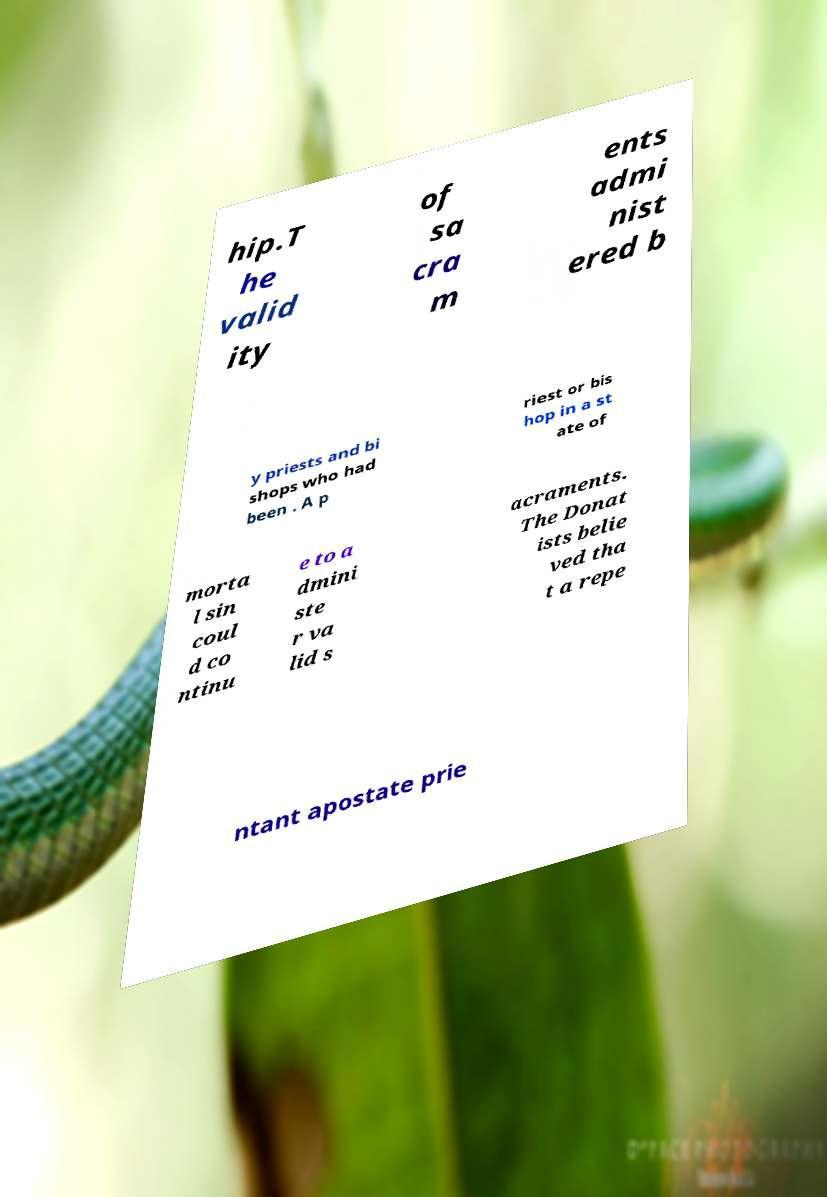For documentation purposes, I need the text within this image transcribed. Could you provide that? hip.T he valid ity of sa cra m ents admi nist ered b y priests and bi shops who had been . A p riest or bis hop in a st ate of morta l sin coul d co ntinu e to a dmini ste r va lid s acraments. The Donat ists belie ved tha t a repe ntant apostate prie 